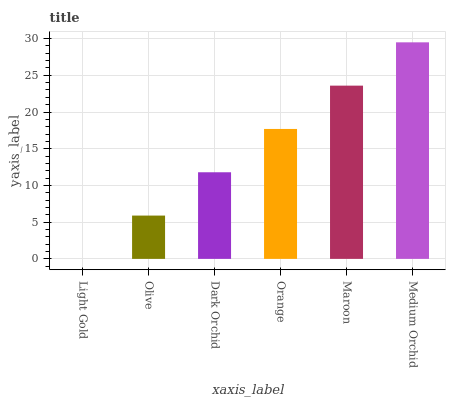Is Medium Orchid the maximum?
Answer yes or no. Yes. Is Olive the minimum?
Answer yes or no. No. Is Olive the maximum?
Answer yes or no. No. Is Olive greater than Light Gold?
Answer yes or no. Yes. Is Light Gold less than Olive?
Answer yes or no. Yes. Is Light Gold greater than Olive?
Answer yes or no. No. Is Olive less than Light Gold?
Answer yes or no. No. Is Orange the high median?
Answer yes or no. Yes. Is Dark Orchid the low median?
Answer yes or no. Yes. Is Olive the high median?
Answer yes or no. No. Is Light Gold the low median?
Answer yes or no. No. 